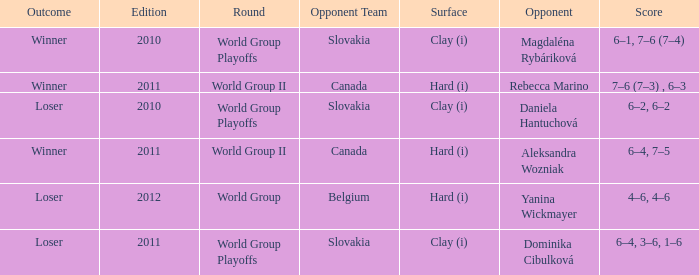What was the game edition when they played on the clay (i) surface and the outcome was a winner? 2010.0. 